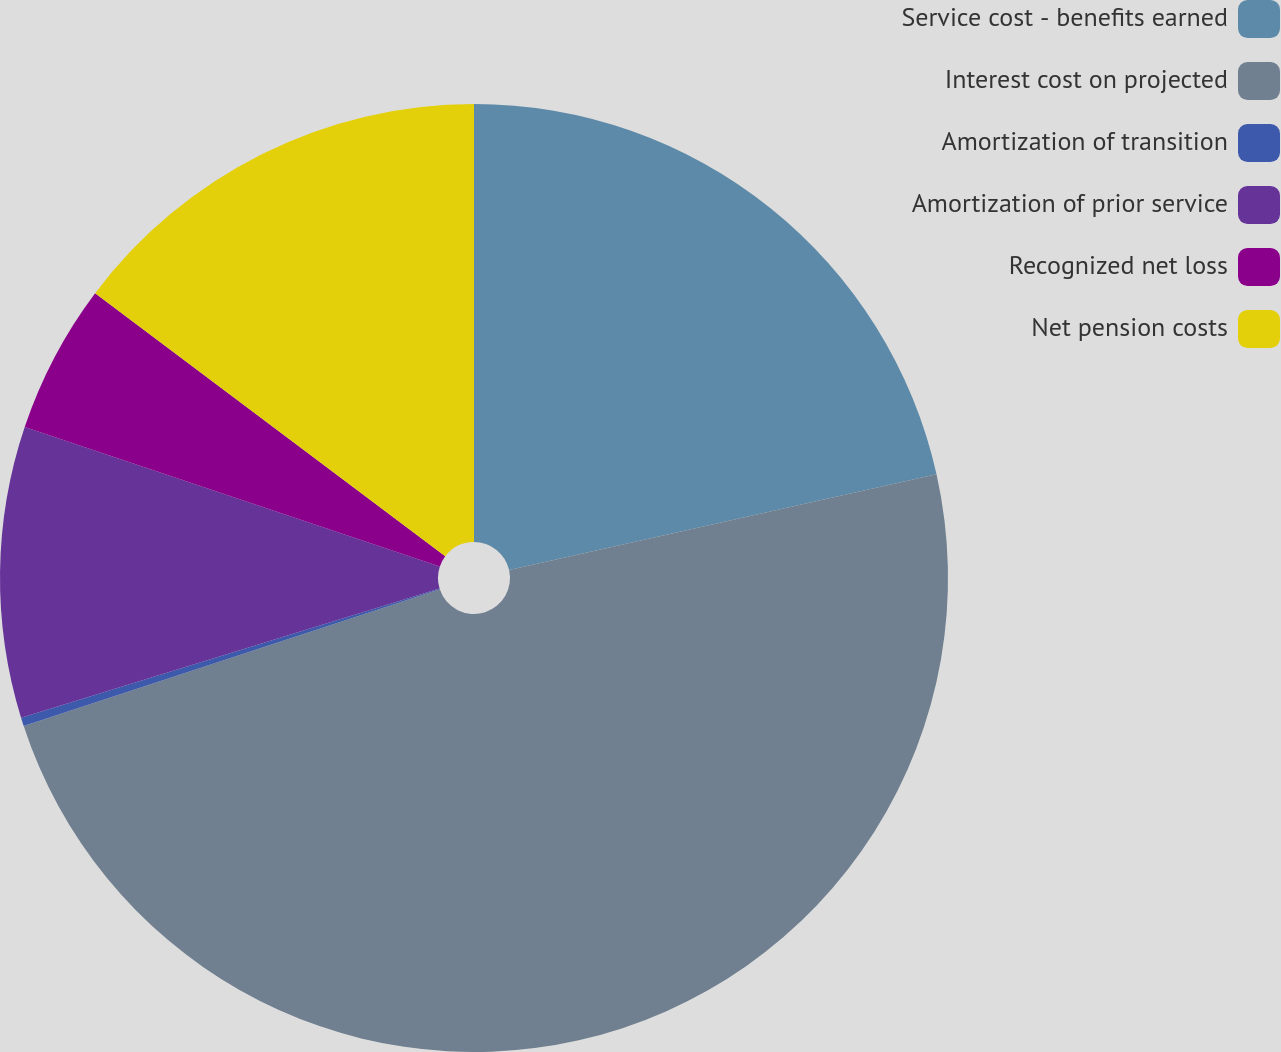<chart> <loc_0><loc_0><loc_500><loc_500><pie_chart><fcel>Service cost - benefits earned<fcel>Interest cost on projected<fcel>Amortization of transition<fcel>Amortization of prior service<fcel>Recognized net loss<fcel>Net pension costs<nl><fcel>21.49%<fcel>48.46%<fcel>0.29%<fcel>9.92%<fcel>5.1%<fcel>14.74%<nl></chart> 